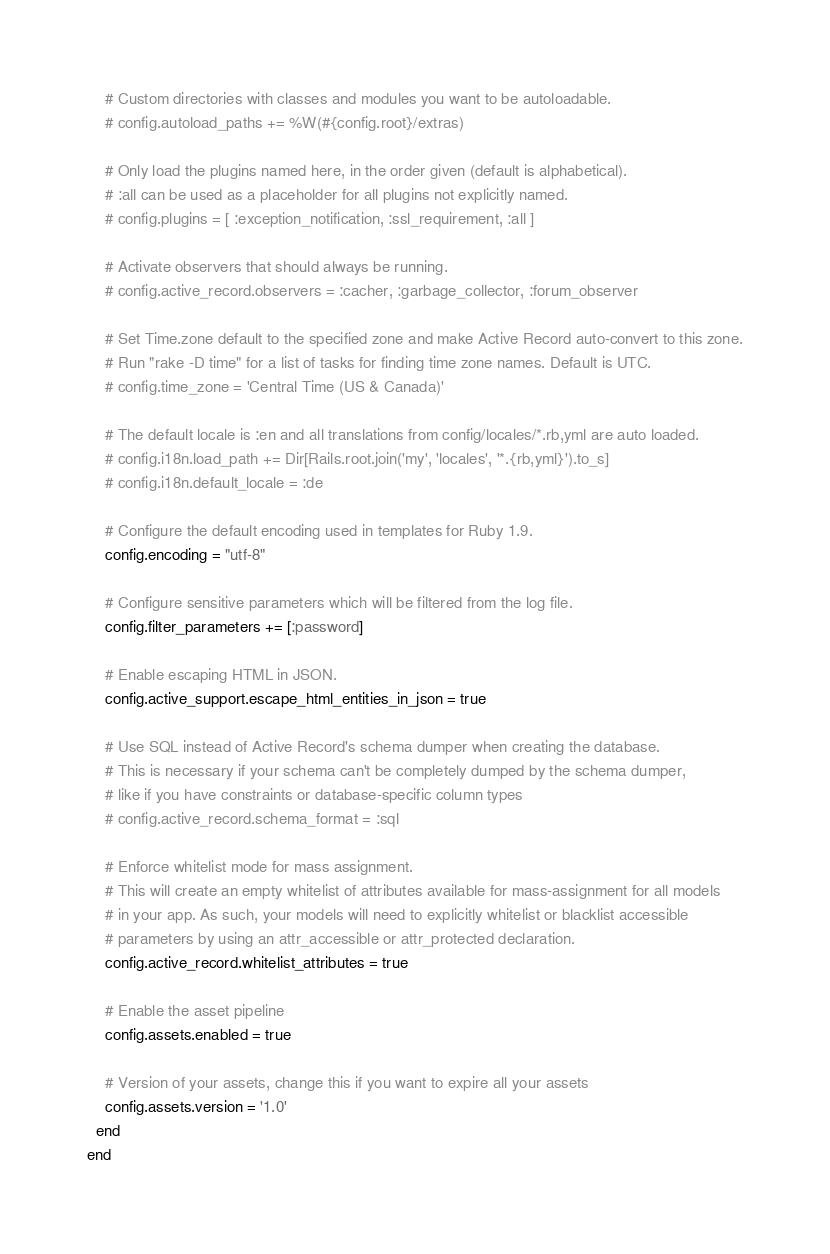<code> <loc_0><loc_0><loc_500><loc_500><_Ruby_>
    # Custom directories with classes and modules you want to be autoloadable.
    # config.autoload_paths += %W(#{config.root}/extras)

    # Only load the plugins named here, in the order given (default is alphabetical).
    # :all can be used as a placeholder for all plugins not explicitly named.
    # config.plugins = [ :exception_notification, :ssl_requirement, :all ]

    # Activate observers that should always be running.
    # config.active_record.observers = :cacher, :garbage_collector, :forum_observer

    # Set Time.zone default to the specified zone and make Active Record auto-convert to this zone.
    # Run "rake -D time" for a list of tasks for finding time zone names. Default is UTC.
    # config.time_zone = 'Central Time (US & Canada)'

    # The default locale is :en and all translations from config/locales/*.rb,yml are auto loaded.
    # config.i18n.load_path += Dir[Rails.root.join('my', 'locales', '*.{rb,yml}').to_s]
    # config.i18n.default_locale = :de

    # Configure the default encoding used in templates for Ruby 1.9.
    config.encoding = "utf-8"

    # Configure sensitive parameters which will be filtered from the log file.
    config.filter_parameters += [:password]

    # Enable escaping HTML in JSON.
    config.active_support.escape_html_entities_in_json = true

    # Use SQL instead of Active Record's schema dumper when creating the database.
    # This is necessary if your schema can't be completely dumped by the schema dumper,
    # like if you have constraints or database-specific column types
    # config.active_record.schema_format = :sql

    # Enforce whitelist mode for mass assignment.
    # This will create an empty whitelist of attributes available for mass-assignment for all models
    # in your app. As such, your models will need to explicitly whitelist or blacklist accessible
    # parameters by using an attr_accessible or attr_protected declaration.
    config.active_record.whitelist_attributes = true

    # Enable the asset pipeline
    config.assets.enabled = true

    # Version of your assets, change this if you want to expire all your assets
    config.assets.version = '1.0'
  end
end

</code> 